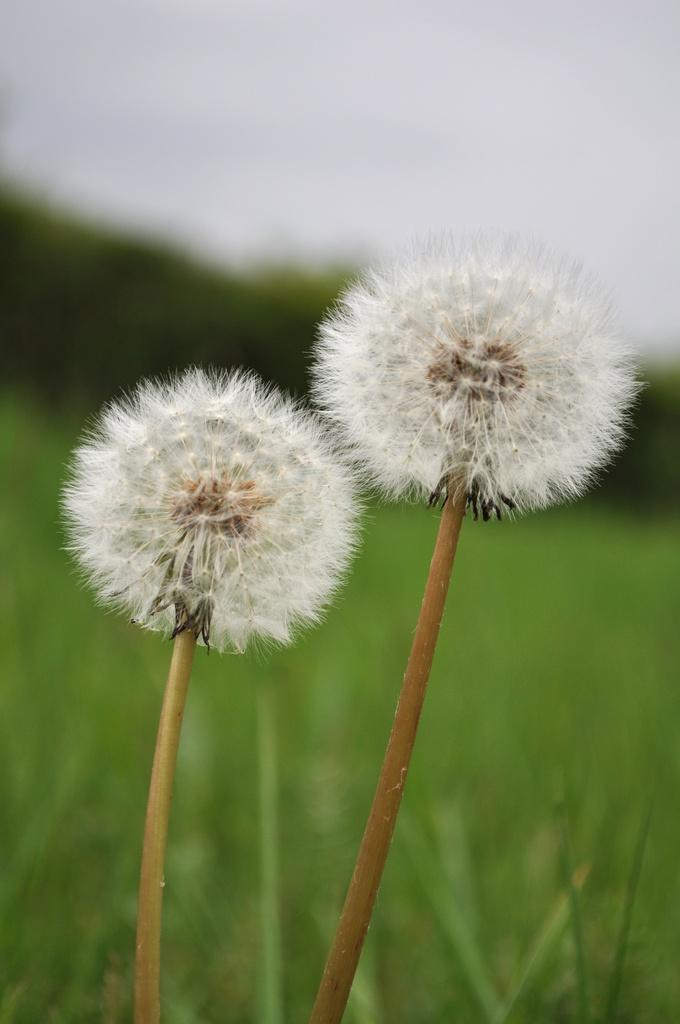What type of flowers can be seen in the image? There are two white flowers in the image. What is on the ground in the image? There is grass on the ground in the image. What can be seen in the background of the image? There are trees and the sky visible in the background of the image. What type of canvas is used to create the border in the image? There is no canvas or border present in the image; it features two white flowers, grass, trees, and the sky. 